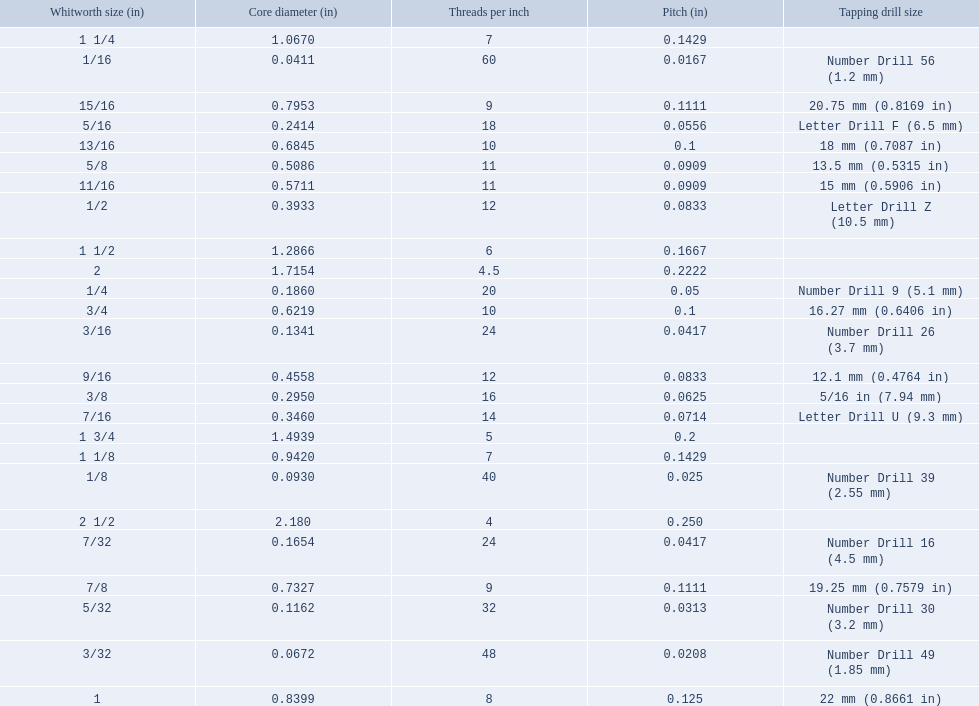What are all the whitworth sizes? 1/16, 3/32, 1/8, 5/32, 3/16, 7/32, 1/4, 5/16, 3/8, 7/16, 1/2, 9/16, 5/8, 11/16, 3/4, 13/16, 7/8, 15/16, 1, 1 1/8, 1 1/4, 1 1/2, 1 3/4, 2, 2 1/2. What are the threads per inch of these sizes? 60, 48, 40, 32, 24, 24, 20, 18, 16, 14, 12, 12, 11, 11, 10, 10, 9, 9, 8, 7, 7, 6, 5, 4.5, 4. Of these, which are 5? 5. What whitworth size has this threads per inch? 1 3/4. 